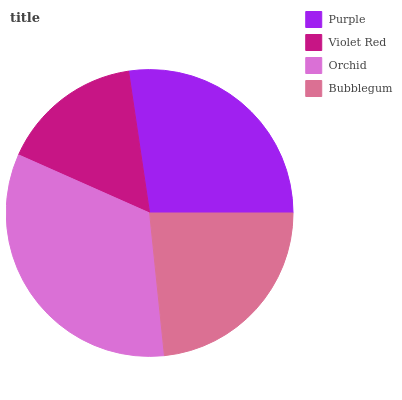Is Violet Red the minimum?
Answer yes or no. Yes. Is Orchid the maximum?
Answer yes or no. Yes. Is Orchid the minimum?
Answer yes or no. No. Is Violet Red the maximum?
Answer yes or no. No. Is Orchid greater than Violet Red?
Answer yes or no. Yes. Is Violet Red less than Orchid?
Answer yes or no. Yes. Is Violet Red greater than Orchid?
Answer yes or no. No. Is Orchid less than Violet Red?
Answer yes or no. No. Is Purple the high median?
Answer yes or no. Yes. Is Bubblegum the low median?
Answer yes or no. Yes. Is Violet Red the high median?
Answer yes or no. No. Is Orchid the low median?
Answer yes or no. No. 